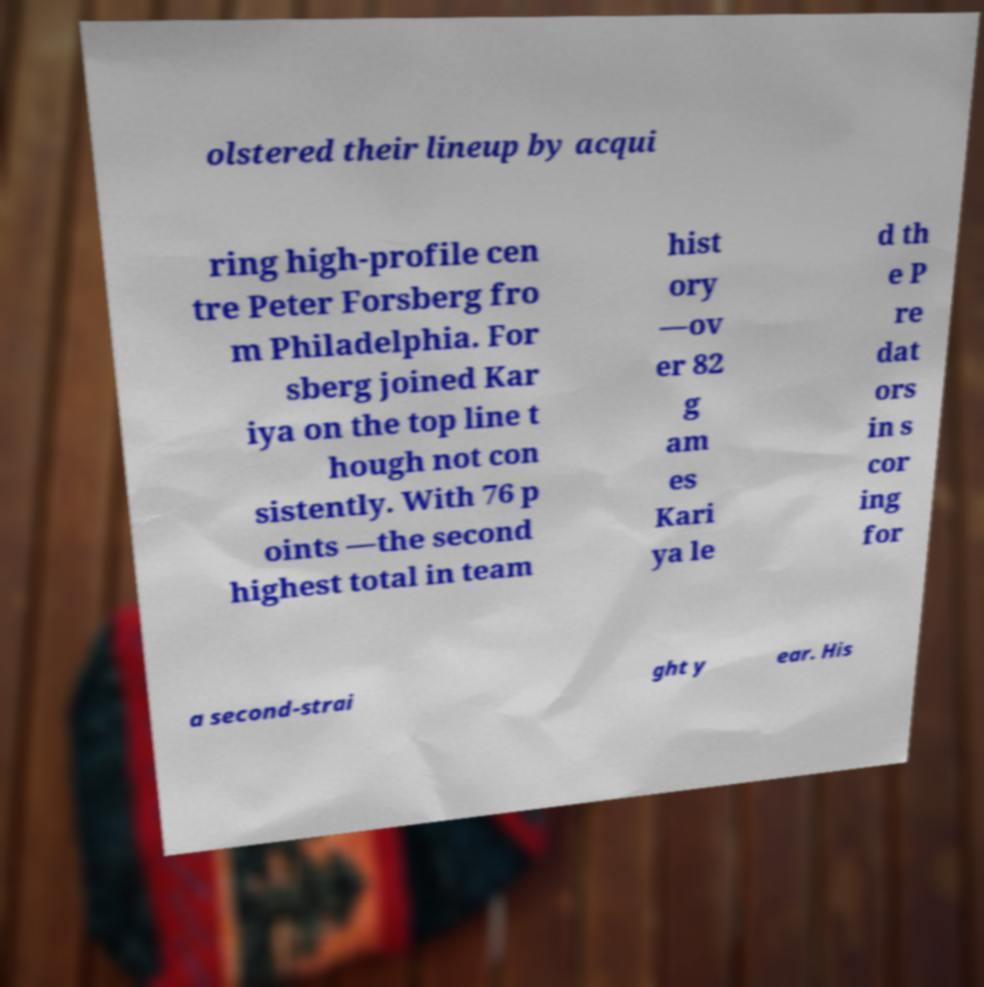Could you extract and type out the text from this image? olstered their lineup by acqui ring high-profile cen tre Peter Forsberg fro m Philadelphia. For sberg joined Kar iya on the top line t hough not con sistently. With 76 p oints —the second highest total in team hist ory —ov er 82 g am es Kari ya le d th e P re dat ors in s cor ing for a second-strai ght y ear. His 